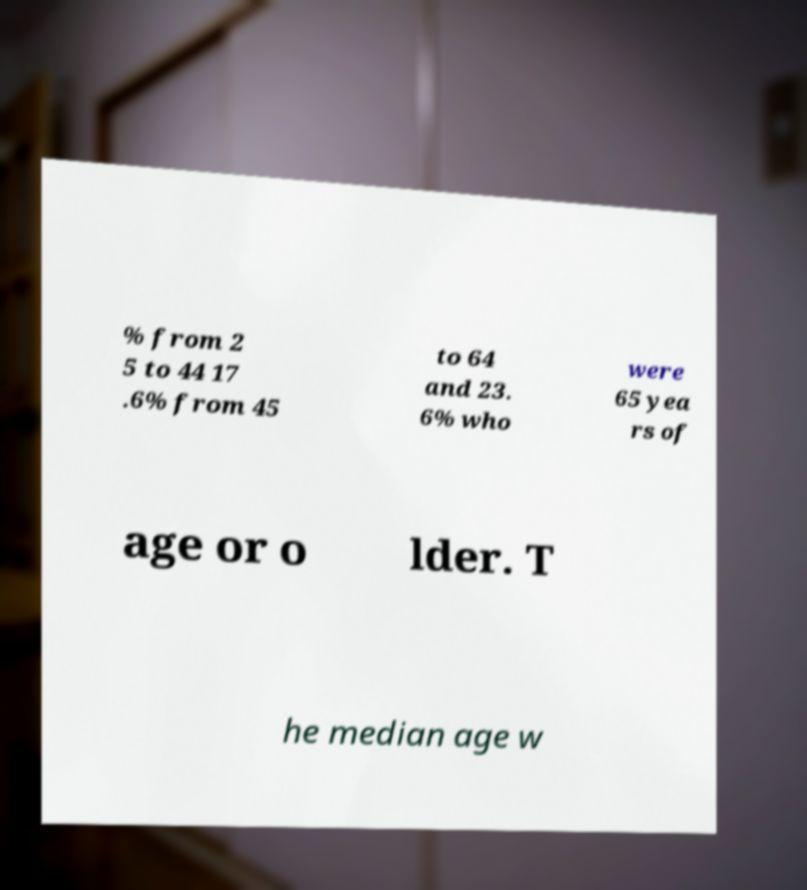Can you read and provide the text displayed in the image?This photo seems to have some interesting text. Can you extract and type it out for me? % from 2 5 to 44 17 .6% from 45 to 64 and 23. 6% who were 65 yea rs of age or o lder. T he median age w 